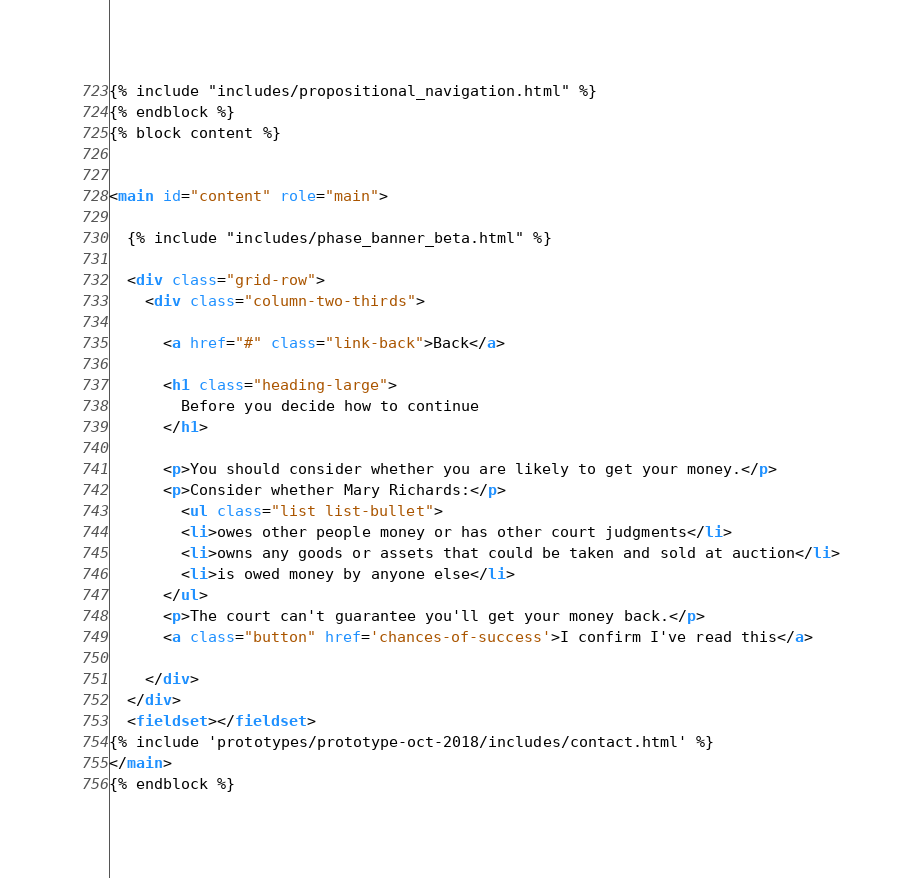<code> <loc_0><loc_0><loc_500><loc_500><_HTML_>
{% include "includes/propositional_navigation.html" %}
{% endblock %}
{% block content %}


<main id="content" role="main">

  {% include "includes/phase_banner_beta.html" %}

  <div class="grid-row">
    <div class="column-two-thirds">

      <a href="#" class="link-back">Back</a>

      <h1 class="heading-large">
        Before you decide how to continue
      </h1>

      <p>You should consider whether you are likely to get your money.</p>
      <p>Consider whether Mary Richards:</p>
        <ul class="list list-bullet">
        <li>owes other people money or has other court judgments</li>
        <li>owns any goods or assets that could be taken and sold at auction</li>
        <li>is owed money by anyone else</li>
      </ul>
      <p>The court can't guarantee you'll get your money back.</p>
      <a class="button" href='chances-of-success'>I confirm I've read this</a>

    </div>
  </div>
  <fieldset></fieldset>
{% include 'prototypes/prototype-oct-2018/includes/contact.html' %}
</main>
{% endblock %}
</code> 